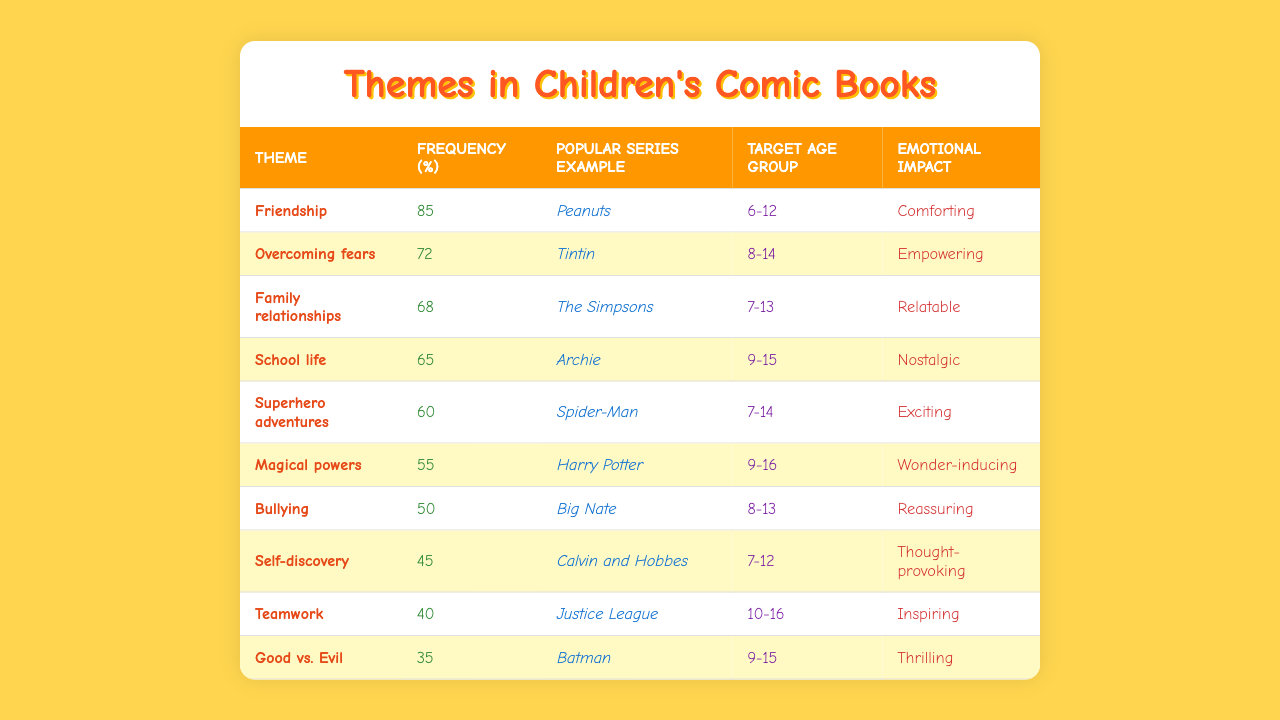What is the most common theme in children's comic books? The theme with the highest frequency is "Friendship," with a frequency of 85%.
Answer: Friendship Which theme is associated with the least emotional impact? The theme "Good vs. Evil," having an emotional impact rated as "Thrilling," suggests it is less comforting compared to others.
Answer: Good vs. Evil What percentage of comic books focus on self-discovery? The percentage of comic books that focus on self-discovery is 45%.
Answer: 45% What theme has a higher frequency: "Superhero adventures" or "Magical powers"? "Superhero adventures" has a frequency of 60%, while "Magical powers" has a frequency of 55%. Therefore, "Superhero adventures" is higher.
Answer: Superhero adventures How many themes have a frequency of 65% or higher? The themes with a frequency of 65% or higher are "Friendship," "Overcoming fears," "Family relationships," and "School life," totaling 4 themes.
Answer: 4 Is there a theme that focuses on bullying? Yes, there is a theme titled "Bullying."
Answer: Yes Which popular series example corresponds to the theme "Self-discovery"? The popular series example corresponding to the theme "Self-discovery" is "Calvin and Hobbes."
Answer: Calvin and Hobbes What is the frequency difference between "Teamwork" and "Bullying"? "Teamwork" has a frequency of 40%, while "Bullying" has a frequency of 50%. The difference is 50% - 40% = 10%.
Answer: 10% Can we conclude that themes related to family relationships occur more than those about school life? Yes, "Family relationships" (68%) has a higher frequency than "School life" (65%).
Answer: Yes Which target age group is the youngest for the theme "Superhero adventures"? The target age group for "Superhero adventures" is 7-14 years, which is the youngest listed among themes.
Answer: 7-14 How are the emotional impacts of "Friendship" and "Bullying" different? "Friendship" is described as "Comforting" while "Bullying" is described as "Reassuring," showing they impact emotions in different, yet positive ways.
Answer: Different 